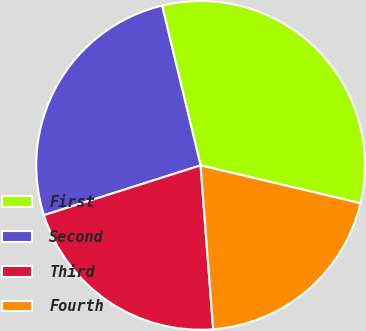Convert chart to OTSL. <chart><loc_0><loc_0><loc_500><loc_500><pie_chart><fcel>First<fcel>Second<fcel>Third<fcel>Fourth<nl><fcel>32.46%<fcel>26.13%<fcel>21.32%<fcel>20.08%<nl></chart> 